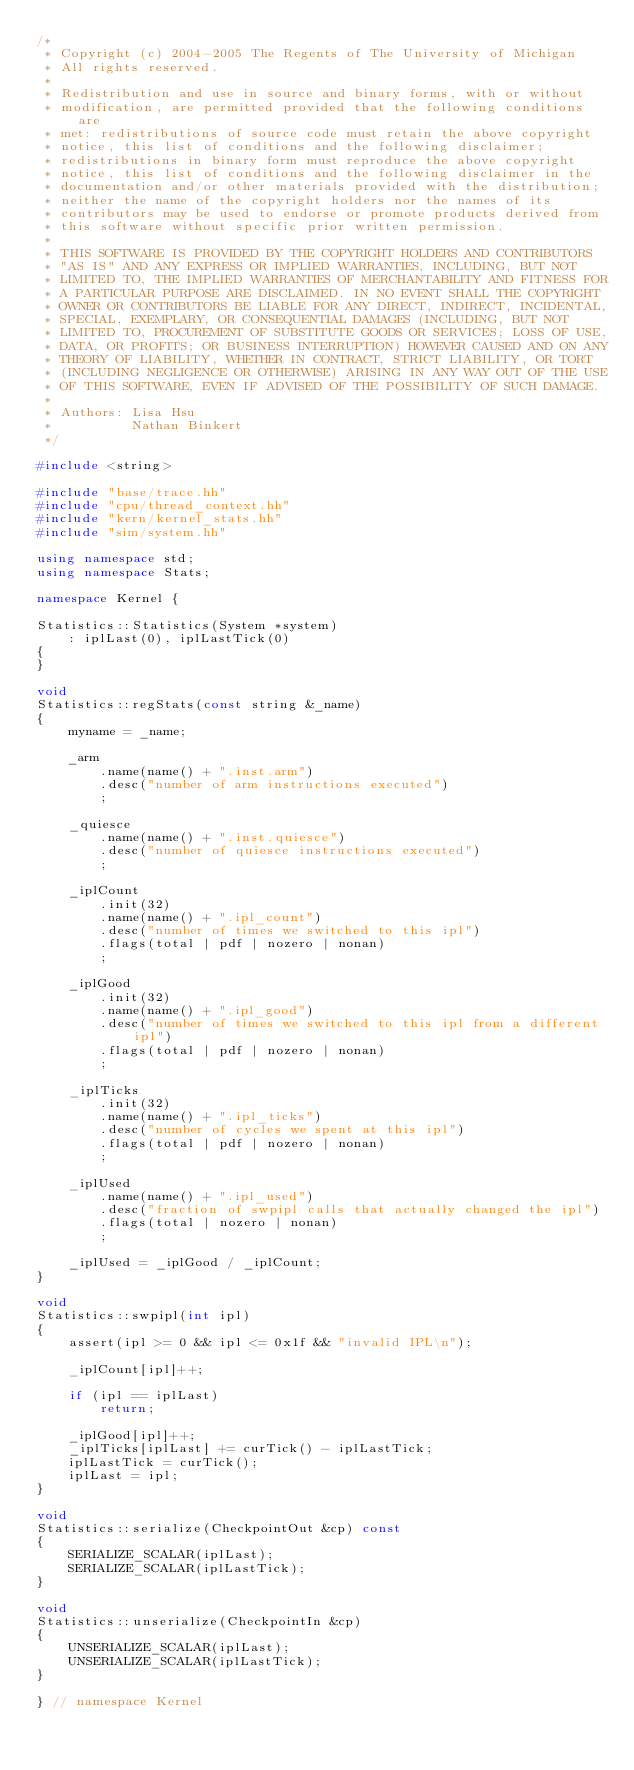Convert code to text. <code><loc_0><loc_0><loc_500><loc_500><_C++_>/*
 * Copyright (c) 2004-2005 The Regents of The University of Michigan
 * All rights reserved.
 *
 * Redistribution and use in source and binary forms, with or without
 * modification, are permitted provided that the following conditions are
 * met: redistributions of source code must retain the above copyright
 * notice, this list of conditions and the following disclaimer;
 * redistributions in binary form must reproduce the above copyright
 * notice, this list of conditions and the following disclaimer in the
 * documentation and/or other materials provided with the distribution;
 * neither the name of the copyright holders nor the names of its
 * contributors may be used to endorse or promote products derived from
 * this software without specific prior written permission.
 *
 * THIS SOFTWARE IS PROVIDED BY THE COPYRIGHT HOLDERS AND CONTRIBUTORS
 * "AS IS" AND ANY EXPRESS OR IMPLIED WARRANTIES, INCLUDING, BUT NOT
 * LIMITED TO, THE IMPLIED WARRANTIES OF MERCHANTABILITY AND FITNESS FOR
 * A PARTICULAR PURPOSE ARE DISCLAIMED. IN NO EVENT SHALL THE COPYRIGHT
 * OWNER OR CONTRIBUTORS BE LIABLE FOR ANY DIRECT, INDIRECT, INCIDENTAL,
 * SPECIAL, EXEMPLARY, OR CONSEQUENTIAL DAMAGES (INCLUDING, BUT NOT
 * LIMITED TO, PROCUREMENT OF SUBSTITUTE GOODS OR SERVICES; LOSS OF USE,
 * DATA, OR PROFITS; OR BUSINESS INTERRUPTION) HOWEVER CAUSED AND ON ANY
 * THEORY OF LIABILITY, WHETHER IN CONTRACT, STRICT LIABILITY, OR TORT
 * (INCLUDING NEGLIGENCE OR OTHERWISE) ARISING IN ANY WAY OUT OF THE USE
 * OF THIS SOFTWARE, EVEN IF ADVISED OF THE POSSIBILITY OF SUCH DAMAGE.
 *
 * Authors: Lisa Hsu
 *          Nathan Binkert
 */

#include <string>

#include "base/trace.hh"
#include "cpu/thread_context.hh"
#include "kern/kernel_stats.hh"
#include "sim/system.hh"

using namespace std;
using namespace Stats;

namespace Kernel {

Statistics::Statistics(System *system)
    : iplLast(0), iplLastTick(0)
{
}

void
Statistics::regStats(const string &_name)
{
    myname = _name;

    _arm
        .name(name() + ".inst.arm")
        .desc("number of arm instructions executed")
        ;

    _quiesce
        .name(name() + ".inst.quiesce")
        .desc("number of quiesce instructions executed")
        ;

    _iplCount
        .init(32)
        .name(name() + ".ipl_count")
        .desc("number of times we switched to this ipl")
        .flags(total | pdf | nozero | nonan)
        ;

    _iplGood
        .init(32)
        .name(name() + ".ipl_good")
        .desc("number of times we switched to this ipl from a different ipl")
        .flags(total | pdf | nozero | nonan)
        ;

    _iplTicks
        .init(32)
        .name(name() + ".ipl_ticks")
        .desc("number of cycles we spent at this ipl")
        .flags(total | pdf | nozero | nonan)
        ;

    _iplUsed
        .name(name() + ".ipl_used")
        .desc("fraction of swpipl calls that actually changed the ipl")
        .flags(total | nozero | nonan)
        ;

    _iplUsed = _iplGood / _iplCount;
}

void
Statistics::swpipl(int ipl)
{
    assert(ipl >= 0 && ipl <= 0x1f && "invalid IPL\n");

    _iplCount[ipl]++;

    if (ipl == iplLast)
        return;

    _iplGood[ipl]++;
    _iplTicks[iplLast] += curTick() - iplLastTick;
    iplLastTick = curTick();
    iplLast = ipl;
}

void
Statistics::serialize(CheckpointOut &cp) const
{
    SERIALIZE_SCALAR(iplLast);
    SERIALIZE_SCALAR(iplLastTick);
}

void
Statistics::unserialize(CheckpointIn &cp)
{
    UNSERIALIZE_SCALAR(iplLast);
    UNSERIALIZE_SCALAR(iplLastTick);
}

} // namespace Kernel
</code> 